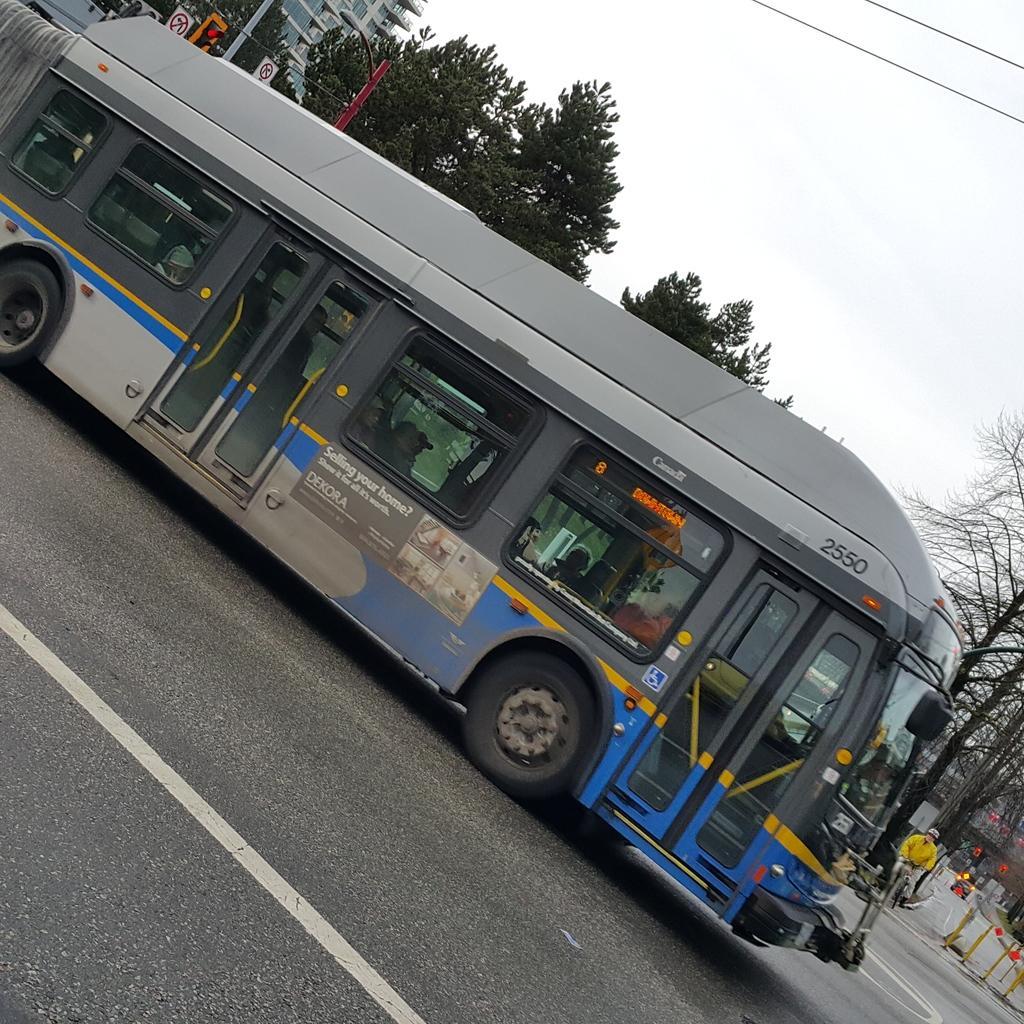Please provide a concise description of this image. At the bottom of the image there is a road. On the road there is a bus with doors, glass windows and posters. Behind the bus there are trees, poles with sign boards. At the top of the image there is a sky and also there are wires. 